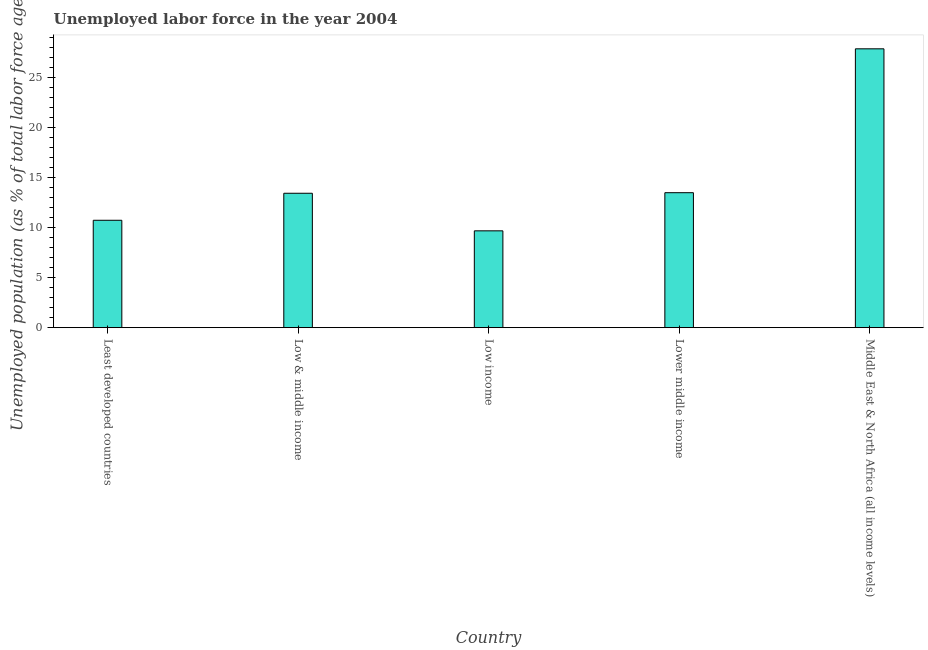What is the title of the graph?
Offer a very short reply. Unemployed labor force in the year 2004. What is the label or title of the Y-axis?
Ensure brevity in your answer.  Unemployed population (as % of total labor force ages 15-24). What is the total unemployed youth population in Least developed countries?
Keep it short and to the point. 10.72. Across all countries, what is the maximum total unemployed youth population?
Offer a very short reply. 27.83. Across all countries, what is the minimum total unemployed youth population?
Make the answer very short. 9.66. In which country was the total unemployed youth population maximum?
Your answer should be compact. Middle East & North Africa (all income levels). What is the sum of the total unemployed youth population?
Ensure brevity in your answer.  75.1. What is the difference between the total unemployed youth population in Least developed countries and Low & middle income?
Offer a very short reply. -2.7. What is the average total unemployed youth population per country?
Give a very brief answer. 15.02. What is the median total unemployed youth population?
Provide a succinct answer. 13.41. In how many countries, is the total unemployed youth population greater than 15 %?
Offer a very short reply. 1. What is the ratio of the total unemployed youth population in Least developed countries to that in Low income?
Offer a very short reply. 1.11. What is the difference between the highest and the second highest total unemployed youth population?
Ensure brevity in your answer.  14.36. What is the difference between the highest and the lowest total unemployed youth population?
Ensure brevity in your answer.  18.17. In how many countries, is the total unemployed youth population greater than the average total unemployed youth population taken over all countries?
Provide a short and direct response. 1. How many bars are there?
Offer a very short reply. 5. Are all the bars in the graph horizontal?
Your answer should be very brief. No. How many countries are there in the graph?
Offer a terse response. 5. What is the difference between two consecutive major ticks on the Y-axis?
Provide a succinct answer. 5. What is the Unemployed population (as % of total labor force ages 15-24) of Least developed countries?
Provide a short and direct response. 10.72. What is the Unemployed population (as % of total labor force ages 15-24) of Low & middle income?
Make the answer very short. 13.41. What is the Unemployed population (as % of total labor force ages 15-24) in Low income?
Give a very brief answer. 9.66. What is the Unemployed population (as % of total labor force ages 15-24) in Lower middle income?
Your answer should be very brief. 13.47. What is the Unemployed population (as % of total labor force ages 15-24) of Middle East & North Africa (all income levels)?
Your answer should be compact. 27.83. What is the difference between the Unemployed population (as % of total labor force ages 15-24) in Least developed countries and Low & middle income?
Offer a terse response. -2.7. What is the difference between the Unemployed population (as % of total labor force ages 15-24) in Least developed countries and Low income?
Provide a short and direct response. 1.06. What is the difference between the Unemployed population (as % of total labor force ages 15-24) in Least developed countries and Lower middle income?
Provide a short and direct response. -2.75. What is the difference between the Unemployed population (as % of total labor force ages 15-24) in Least developed countries and Middle East & North Africa (all income levels)?
Your answer should be compact. -17.11. What is the difference between the Unemployed population (as % of total labor force ages 15-24) in Low & middle income and Low income?
Provide a short and direct response. 3.75. What is the difference between the Unemployed population (as % of total labor force ages 15-24) in Low & middle income and Lower middle income?
Offer a very short reply. -0.06. What is the difference between the Unemployed population (as % of total labor force ages 15-24) in Low & middle income and Middle East & North Africa (all income levels)?
Keep it short and to the point. -14.42. What is the difference between the Unemployed population (as % of total labor force ages 15-24) in Low income and Lower middle income?
Your response must be concise. -3.81. What is the difference between the Unemployed population (as % of total labor force ages 15-24) in Low income and Middle East & North Africa (all income levels)?
Offer a terse response. -18.17. What is the difference between the Unemployed population (as % of total labor force ages 15-24) in Lower middle income and Middle East & North Africa (all income levels)?
Your answer should be very brief. -14.36. What is the ratio of the Unemployed population (as % of total labor force ages 15-24) in Least developed countries to that in Low & middle income?
Provide a short and direct response. 0.8. What is the ratio of the Unemployed population (as % of total labor force ages 15-24) in Least developed countries to that in Low income?
Your answer should be very brief. 1.11. What is the ratio of the Unemployed population (as % of total labor force ages 15-24) in Least developed countries to that in Lower middle income?
Give a very brief answer. 0.8. What is the ratio of the Unemployed population (as % of total labor force ages 15-24) in Least developed countries to that in Middle East & North Africa (all income levels)?
Your answer should be compact. 0.39. What is the ratio of the Unemployed population (as % of total labor force ages 15-24) in Low & middle income to that in Low income?
Your response must be concise. 1.39. What is the ratio of the Unemployed population (as % of total labor force ages 15-24) in Low & middle income to that in Middle East & North Africa (all income levels)?
Offer a very short reply. 0.48. What is the ratio of the Unemployed population (as % of total labor force ages 15-24) in Low income to that in Lower middle income?
Provide a short and direct response. 0.72. What is the ratio of the Unemployed population (as % of total labor force ages 15-24) in Low income to that in Middle East & North Africa (all income levels)?
Make the answer very short. 0.35. What is the ratio of the Unemployed population (as % of total labor force ages 15-24) in Lower middle income to that in Middle East & North Africa (all income levels)?
Your response must be concise. 0.48. 